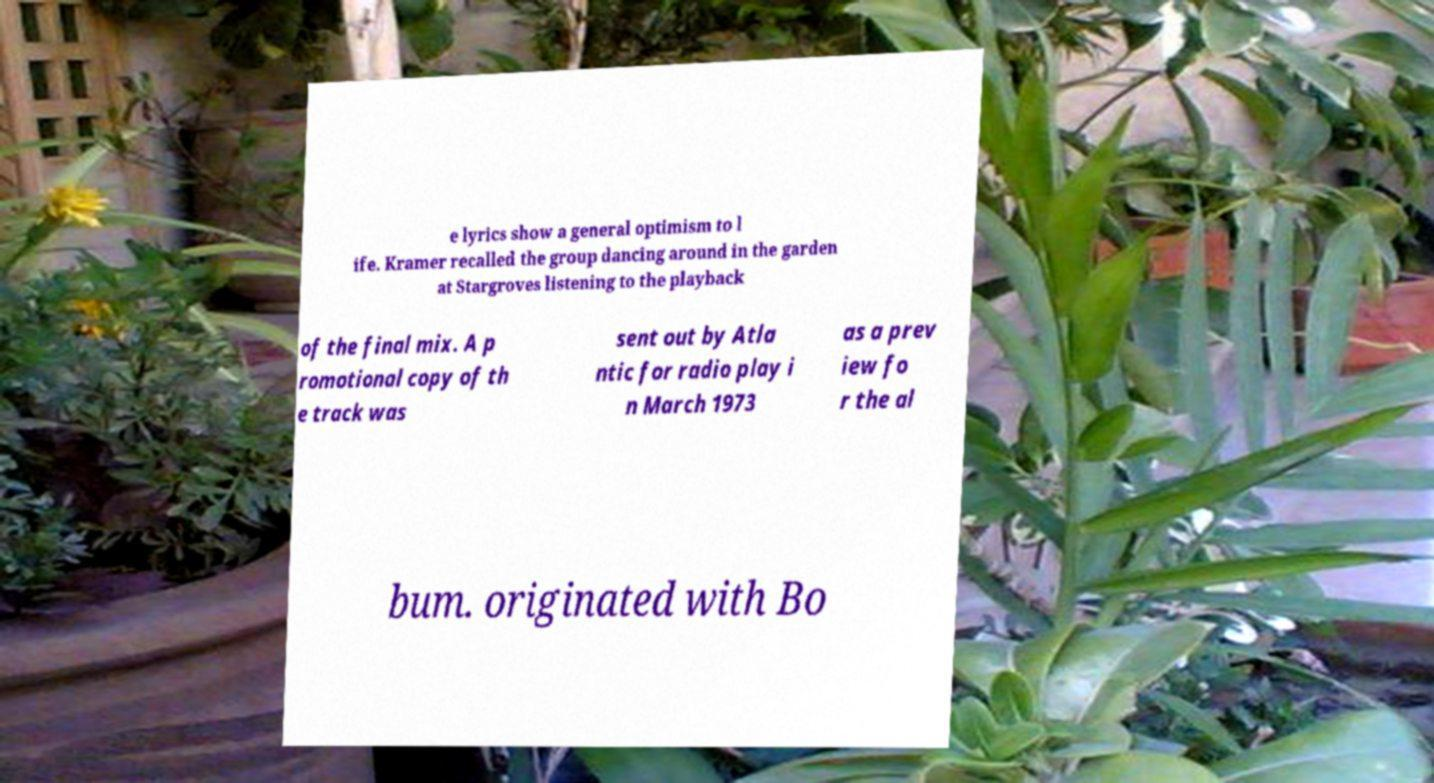Can you read and provide the text displayed in the image?This photo seems to have some interesting text. Can you extract and type it out for me? e lyrics show a general optimism to l ife. Kramer recalled the group dancing around in the garden at Stargroves listening to the playback of the final mix. A p romotional copy of th e track was sent out by Atla ntic for radio play i n March 1973 as a prev iew fo r the al bum. originated with Bo 